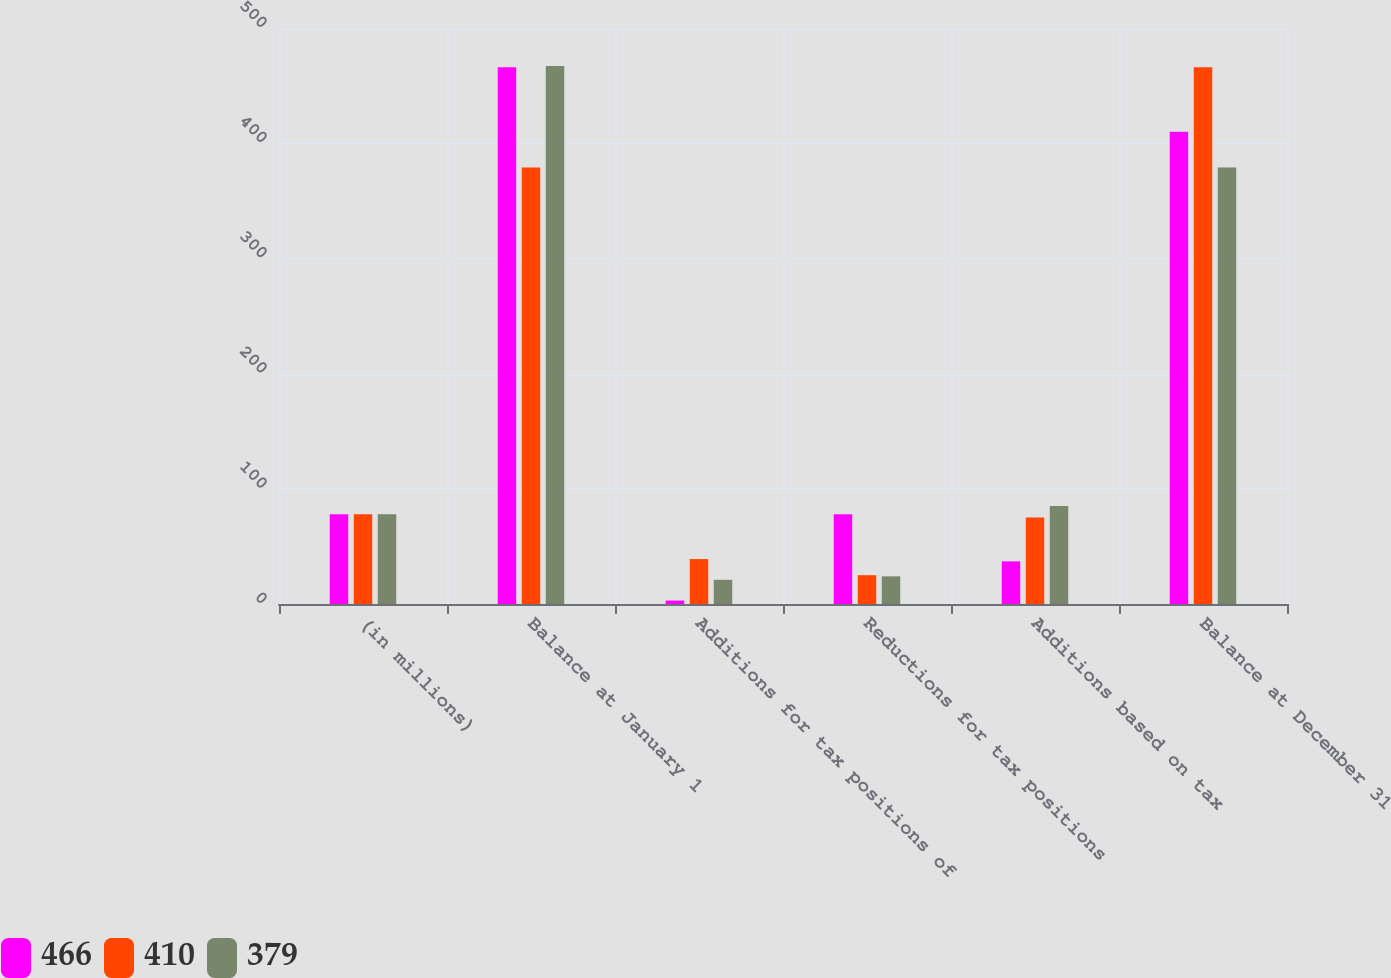Convert chart to OTSL. <chart><loc_0><loc_0><loc_500><loc_500><stacked_bar_chart><ecel><fcel>(in millions)<fcel>Balance at January 1<fcel>Additions for tax positions of<fcel>Reductions for tax positions<fcel>Additions based on tax<fcel>Balance at December 31<nl><fcel>466<fcel>78<fcel>466<fcel>3<fcel>78<fcel>37<fcel>410<nl><fcel>410<fcel>78<fcel>379<fcel>39<fcel>25<fcel>75<fcel>466<nl><fcel>379<fcel>78<fcel>467<fcel>21<fcel>24<fcel>85<fcel>379<nl></chart> 